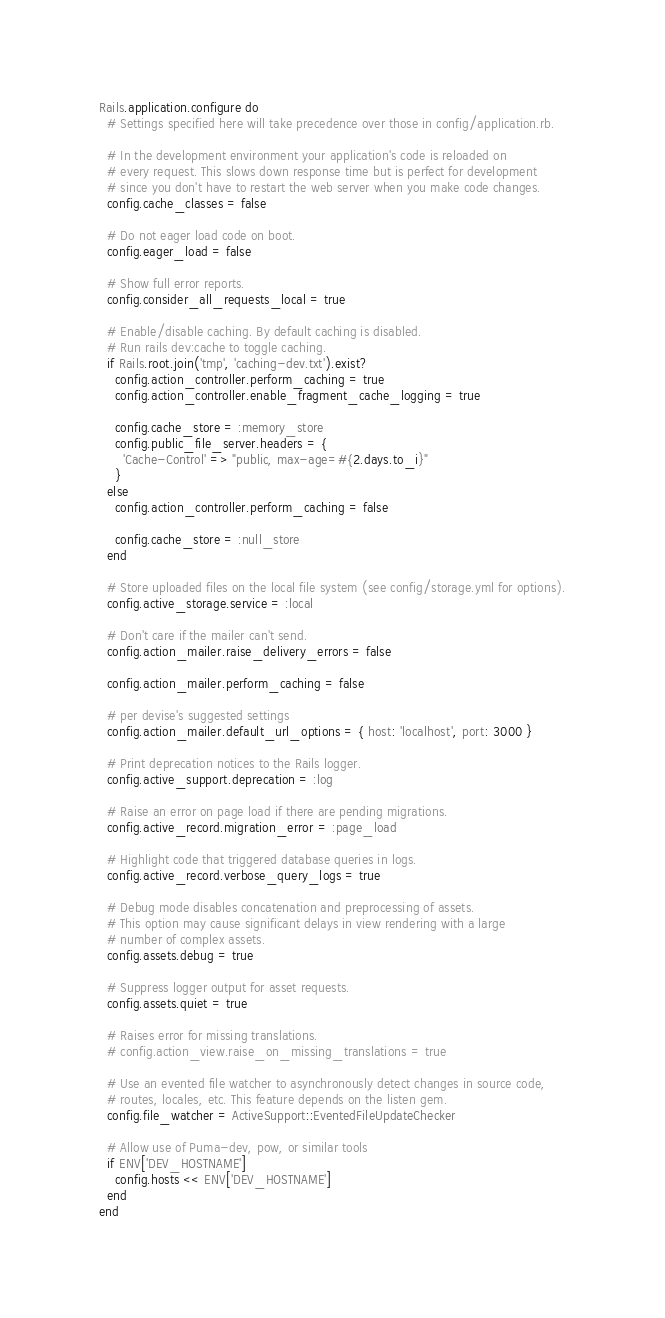Convert code to text. <code><loc_0><loc_0><loc_500><loc_500><_Ruby_>Rails.application.configure do
  # Settings specified here will take precedence over those in config/application.rb.

  # In the development environment your application's code is reloaded on
  # every request. This slows down response time but is perfect for development
  # since you don't have to restart the web server when you make code changes.
  config.cache_classes = false

  # Do not eager load code on boot.
  config.eager_load = false

  # Show full error reports.
  config.consider_all_requests_local = true

  # Enable/disable caching. By default caching is disabled.
  # Run rails dev:cache to toggle caching.
  if Rails.root.join('tmp', 'caching-dev.txt').exist?
    config.action_controller.perform_caching = true
    config.action_controller.enable_fragment_cache_logging = true

    config.cache_store = :memory_store
    config.public_file_server.headers = {
      'Cache-Control' => "public, max-age=#{2.days.to_i}"
    }
  else
    config.action_controller.perform_caching = false

    config.cache_store = :null_store
  end

  # Store uploaded files on the local file system (see config/storage.yml for options).
  config.active_storage.service = :local

  # Don't care if the mailer can't send.
  config.action_mailer.raise_delivery_errors = false

  config.action_mailer.perform_caching = false

  # per devise's suggested settings
  config.action_mailer.default_url_options = { host: 'localhost', port: 3000 }

  # Print deprecation notices to the Rails logger.
  config.active_support.deprecation = :log

  # Raise an error on page load if there are pending migrations.
  config.active_record.migration_error = :page_load

  # Highlight code that triggered database queries in logs.
  config.active_record.verbose_query_logs = true

  # Debug mode disables concatenation and preprocessing of assets.
  # This option may cause significant delays in view rendering with a large
  # number of complex assets.
  config.assets.debug = true

  # Suppress logger output for asset requests.
  config.assets.quiet = true

  # Raises error for missing translations.
  # config.action_view.raise_on_missing_translations = true

  # Use an evented file watcher to asynchronously detect changes in source code,
  # routes, locales, etc. This feature depends on the listen gem.
  config.file_watcher = ActiveSupport::EventedFileUpdateChecker

  # Allow use of Puma-dev, pow, or similar tools
  if ENV['DEV_HOSTNAME']
    config.hosts << ENV['DEV_HOSTNAME']
  end
end
</code> 